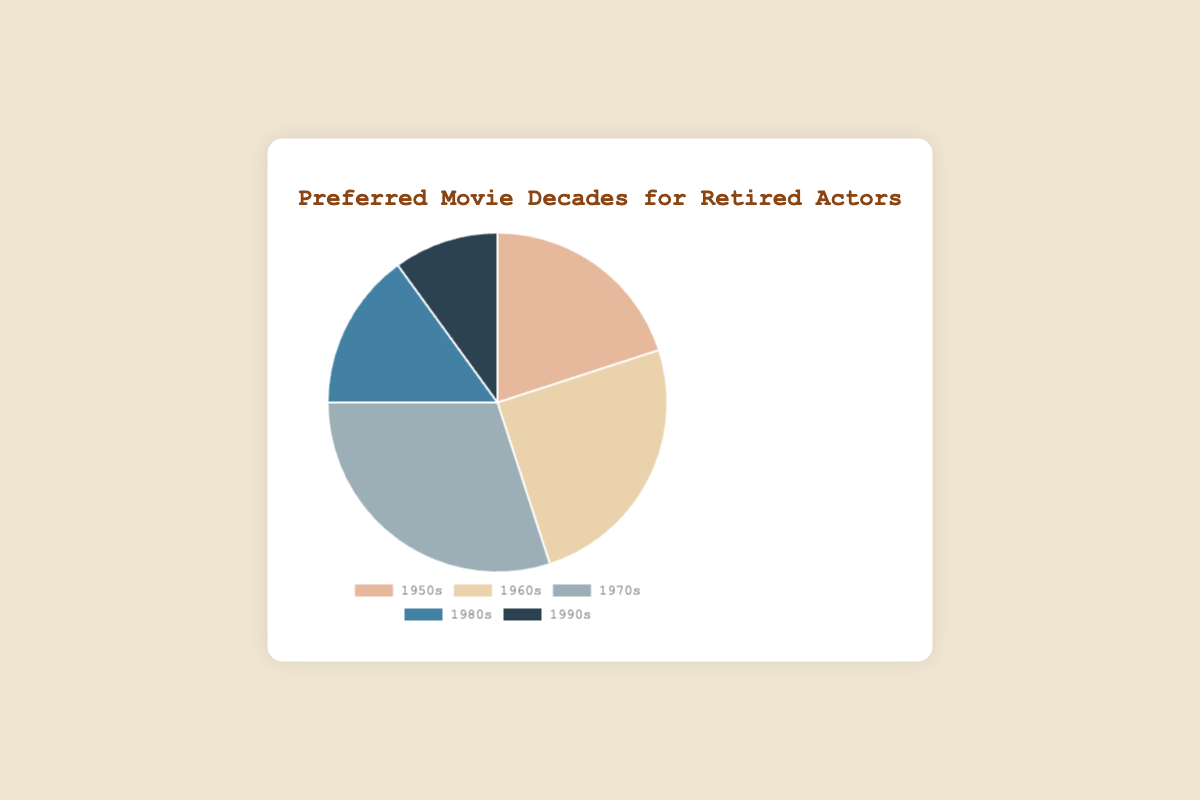What decade is the most preferred for movies among retired actors? The pie chart shows the percentage distribution of preferred movie decades. The segment representing the 1970s is the largest, indicating it is the most preferred decade.
Answer: 1970s Which decade has the smallest percentage of preferred movie watching? By looking at the pie chart, the segment corresponding to the 1990s is the smallest, indicating it has the lowest percentage.
Answer: 1990s What is the combined percentage of retired actors who prefer movies from the 1980s and 1990s? The chart shows the 1980s has 15% and the 1990s has 10%. Adding these together gives 15% + 10% = 25%.
Answer: 25% How does the preference for 1960s movies compare to the 1950s? The pie chart shows the percentages for 1950s and 1960s. The 1960s have 25%, while the 1950s have 20%. Comparing these, 25% is greater than 20%.
Answer: 1960s > 1950s What percentage of retired actors prefer movies from before the 1970s? Adding the percentages for the 1950s and 1960s: 20% (1950s) + 25% (1960s) = 45%.
Answer: 45% If you combine the preferences for the 1950s and 1970s, what is the total percentage? According to the chart, the 1950s have 20% and the 1970s have 30%. Summing these gives 20% + 30% = 50%.
Answer: 50% Which decades together account for half of the retired actors' preferences? To find this, consider combinations of decades. The 1970s (30%) and 1950s (20%) together make 50%, which accounts for half.
Answer: 1950s and 1970s What is the difference in percentage points between the most and least preferred decades? The 1970s have the highest preference at 30%, and the 1990s the lowest at 10%. The difference is 30% - 10% = 20 percentage points.
Answer: 20 percentage points What color represents the data for the 1980s in the pie chart? From the pie chart’s description, the 1980s are represented by the color blue.
Answer: blue 